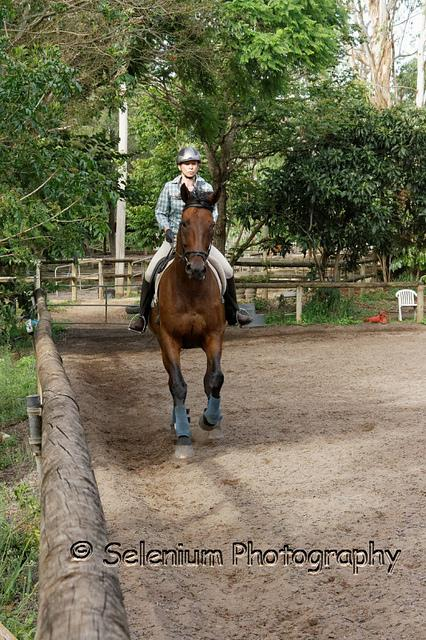In which setting is this person? woods 